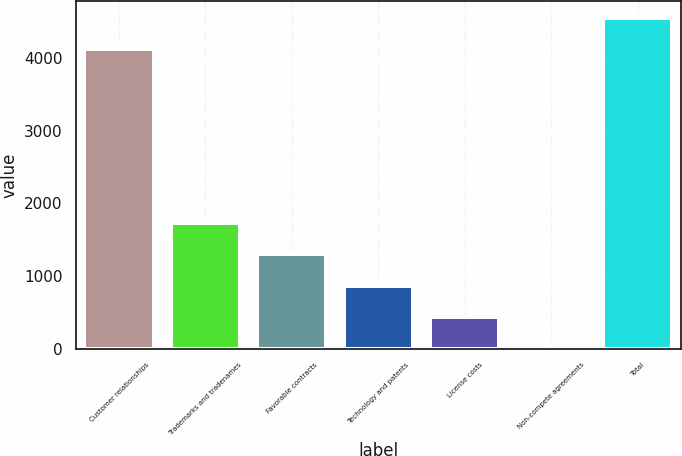Convert chart to OTSL. <chart><loc_0><loc_0><loc_500><loc_500><bar_chart><fcel>Customer relationships<fcel>Trademarks and tradenames<fcel>Favorable contracts<fcel>Technology and patents<fcel>License costs<fcel>Non-compete agreements<fcel>Total<nl><fcel>4123.7<fcel>1729.36<fcel>1297.87<fcel>866.38<fcel>434.89<fcel>3.4<fcel>4555.19<nl></chart> 